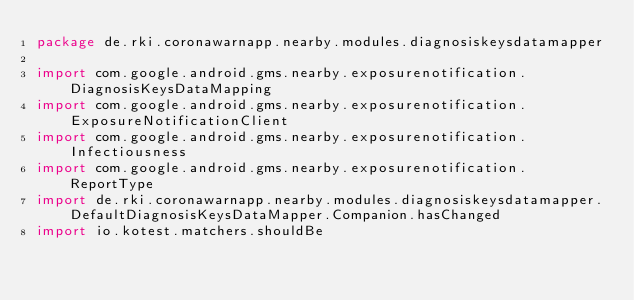Convert code to text. <code><loc_0><loc_0><loc_500><loc_500><_Kotlin_>package de.rki.coronawarnapp.nearby.modules.diagnosiskeysdatamapper

import com.google.android.gms.nearby.exposurenotification.DiagnosisKeysDataMapping
import com.google.android.gms.nearby.exposurenotification.ExposureNotificationClient
import com.google.android.gms.nearby.exposurenotification.Infectiousness
import com.google.android.gms.nearby.exposurenotification.ReportType
import de.rki.coronawarnapp.nearby.modules.diagnosiskeysdatamapper.DefaultDiagnosisKeysDataMapper.Companion.hasChanged
import io.kotest.matchers.shouldBe</code> 